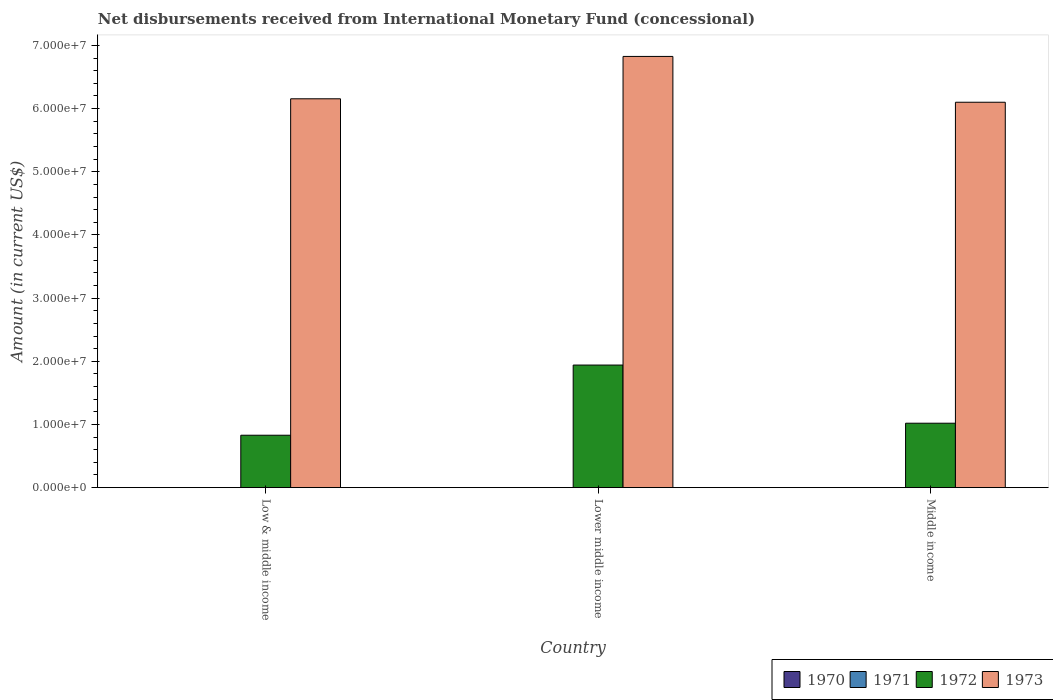How many groups of bars are there?
Provide a short and direct response. 3. Are the number of bars per tick equal to the number of legend labels?
Give a very brief answer. No. How many bars are there on the 1st tick from the left?
Provide a succinct answer. 2. What is the label of the 2nd group of bars from the left?
Ensure brevity in your answer.  Lower middle income. What is the amount of disbursements received from International Monetary Fund in 1971 in Middle income?
Ensure brevity in your answer.  0. Across all countries, what is the maximum amount of disbursements received from International Monetary Fund in 1973?
Your answer should be very brief. 6.83e+07. Across all countries, what is the minimum amount of disbursements received from International Monetary Fund in 1970?
Provide a short and direct response. 0. What is the total amount of disbursements received from International Monetary Fund in 1972 in the graph?
Your answer should be very brief. 3.79e+07. What is the difference between the amount of disbursements received from International Monetary Fund in 1972 in Lower middle income and that in Middle income?
Your response must be concise. 9.21e+06. What is the difference between the amount of disbursements received from International Monetary Fund in 1971 in Middle income and the amount of disbursements received from International Monetary Fund in 1972 in Lower middle income?
Give a very brief answer. -1.94e+07. What is the average amount of disbursements received from International Monetary Fund in 1973 per country?
Offer a terse response. 6.36e+07. What is the difference between the amount of disbursements received from International Monetary Fund of/in 1973 and amount of disbursements received from International Monetary Fund of/in 1972 in Low & middle income?
Provide a succinct answer. 5.33e+07. In how many countries, is the amount of disbursements received from International Monetary Fund in 1971 greater than 22000000 US$?
Give a very brief answer. 0. What is the ratio of the amount of disbursements received from International Monetary Fund in 1972 in Lower middle income to that in Middle income?
Make the answer very short. 1.9. Is the difference between the amount of disbursements received from International Monetary Fund in 1973 in Low & middle income and Lower middle income greater than the difference between the amount of disbursements received from International Monetary Fund in 1972 in Low & middle income and Lower middle income?
Make the answer very short. Yes. What is the difference between the highest and the second highest amount of disbursements received from International Monetary Fund in 1972?
Your response must be concise. 9.21e+06. What is the difference between the highest and the lowest amount of disbursements received from International Monetary Fund in 1973?
Your answer should be compact. 7.25e+06. In how many countries, is the amount of disbursements received from International Monetary Fund in 1973 greater than the average amount of disbursements received from International Monetary Fund in 1973 taken over all countries?
Keep it short and to the point. 1. How many bars are there?
Your answer should be very brief. 6. Are all the bars in the graph horizontal?
Offer a very short reply. No. Are the values on the major ticks of Y-axis written in scientific E-notation?
Provide a short and direct response. Yes. Does the graph contain grids?
Offer a terse response. No. Where does the legend appear in the graph?
Offer a terse response. Bottom right. What is the title of the graph?
Offer a terse response. Net disbursements received from International Monetary Fund (concessional). Does "2009" appear as one of the legend labels in the graph?
Make the answer very short. No. What is the Amount (in current US$) in 1972 in Low & middle income?
Ensure brevity in your answer.  8.30e+06. What is the Amount (in current US$) of 1973 in Low & middle income?
Your response must be concise. 6.16e+07. What is the Amount (in current US$) of 1970 in Lower middle income?
Your answer should be very brief. 0. What is the Amount (in current US$) in 1972 in Lower middle income?
Offer a terse response. 1.94e+07. What is the Amount (in current US$) in 1973 in Lower middle income?
Provide a short and direct response. 6.83e+07. What is the Amount (in current US$) in 1970 in Middle income?
Offer a terse response. 0. What is the Amount (in current US$) of 1972 in Middle income?
Your answer should be compact. 1.02e+07. What is the Amount (in current US$) in 1973 in Middle income?
Offer a very short reply. 6.10e+07. Across all countries, what is the maximum Amount (in current US$) of 1972?
Your answer should be very brief. 1.94e+07. Across all countries, what is the maximum Amount (in current US$) in 1973?
Provide a short and direct response. 6.83e+07. Across all countries, what is the minimum Amount (in current US$) in 1972?
Offer a terse response. 8.30e+06. Across all countries, what is the minimum Amount (in current US$) in 1973?
Offer a terse response. 6.10e+07. What is the total Amount (in current US$) in 1970 in the graph?
Give a very brief answer. 0. What is the total Amount (in current US$) of 1972 in the graph?
Your answer should be very brief. 3.79e+07. What is the total Amount (in current US$) in 1973 in the graph?
Make the answer very short. 1.91e+08. What is the difference between the Amount (in current US$) in 1972 in Low & middle income and that in Lower middle income?
Offer a very short reply. -1.11e+07. What is the difference between the Amount (in current US$) in 1973 in Low & middle income and that in Lower middle income?
Your answer should be compact. -6.70e+06. What is the difference between the Amount (in current US$) in 1972 in Low & middle income and that in Middle income?
Offer a very short reply. -1.90e+06. What is the difference between the Amount (in current US$) in 1973 in Low & middle income and that in Middle income?
Make the answer very short. 5.46e+05. What is the difference between the Amount (in current US$) in 1972 in Lower middle income and that in Middle income?
Provide a short and direct response. 9.21e+06. What is the difference between the Amount (in current US$) in 1973 in Lower middle income and that in Middle income?
Your response must be concise. 7.25e+06. What is the difference between the Amount (in current US$) of 1972 in Low & middle income and the Amount (in current US$) of 1973 in Lower middle income?
Offer a very short reply. -6.00e+07. What is the difference between the Amount (in current US$) in 1972 in Low & middle income and the Amount (in current US$) in 1973 in Middle income?
Your answer should be very brief. -5.27e+07. What is the difference between the Amount (in current US$) of 1972 in Lower middle income and the Amount (in current US$) of 1973 in Middle income?
Your answer should be very brief. -4.16e+07. What is the average Amount (in current US$) in 1972 per country?
Give a very brief answer. 1.26e+07. What is the average Amount (in current US$) of 1973 per country?
Ensure brevity in your answer.  6.36e+07. What is the difference between the Amount (in current US$) of 1972 and Amount (in current US$) of 1973 in Low & middle income?
Keep it short and to the point. -5.33e+07. What is the difference between the Amount (in current US$) of 1972 and Amount (in current US$) of 1973 in Lower middle income?
Provide a short and direct response. -4.89e+07. What is the difference between the Amount (in current US$) in 1972 and Amount (in current US$) in 1973 in Middle income?
Keep it short and to the point. -5.08e+07. What is the ratio of the Amount (in current US$) in 1972 in Low & middle income to that in Lower middle income?
Offer a terse response. 0.43. What is the ratio of the Amount (in current US$) in 1973 in Low & middle income to that in Lower middle income?
Offer a very short reply. 0.9. What is the ratio of the Amount (in current US$) of 1972 in Low & middle income to that in Middle income?
Ensure brevity in your answer.  0.81. What is the ratio of the Amount (in current US$) of 1972 in Lower middle income to that in Middle income?
Offer a very short reply. 1.9. What is the ratio of the Amount (in current US$) of 1973 in Lower middle income to that in Middle income?
Your answer should be very brief. 1.12. What is the difference between the highest and the second highest Amount (in current US$) of 1972?
Give a very brief answer. 9.21e+06. What is the difference between the highest and the second highest Amount (in current US$) of 1973?
Offer a terse response. 6.70e+06. What is the difference between the highest and the lowest Amount (in current US$) in 1972?
Make the answer very short. 1.11e+07. What is the difference between the highest and the lowest Amount (in current US$) in 1973?
Your response must be concise. 7.25e+06. 